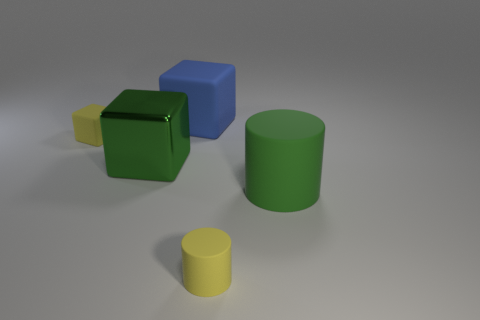Subtract all yellow blocks. How many blocks are left? 2 Add 1 blue rubber things. How many objects exist? 6 Subtract all green cylinders. How many cylinders are left? 1 Subtract 2 cylinders. How many cylinders are left? 0 Subtract all blue cylinders. Subtract all gray cubes. How many cylinders are left? 2 Subtract all purple spheres. How many blue cubes are left? 1 Subtract all tiny cyan rubber cubes. Subtract all large blue rubber blocks. How many objects are left? 4 Add 3 tiny objects. How many tiny objects are left? 5 Add 4 big red shiny things. How many big red shiny things exist? 4 Subtract 0 blue spheres. How many objects are left? 5 